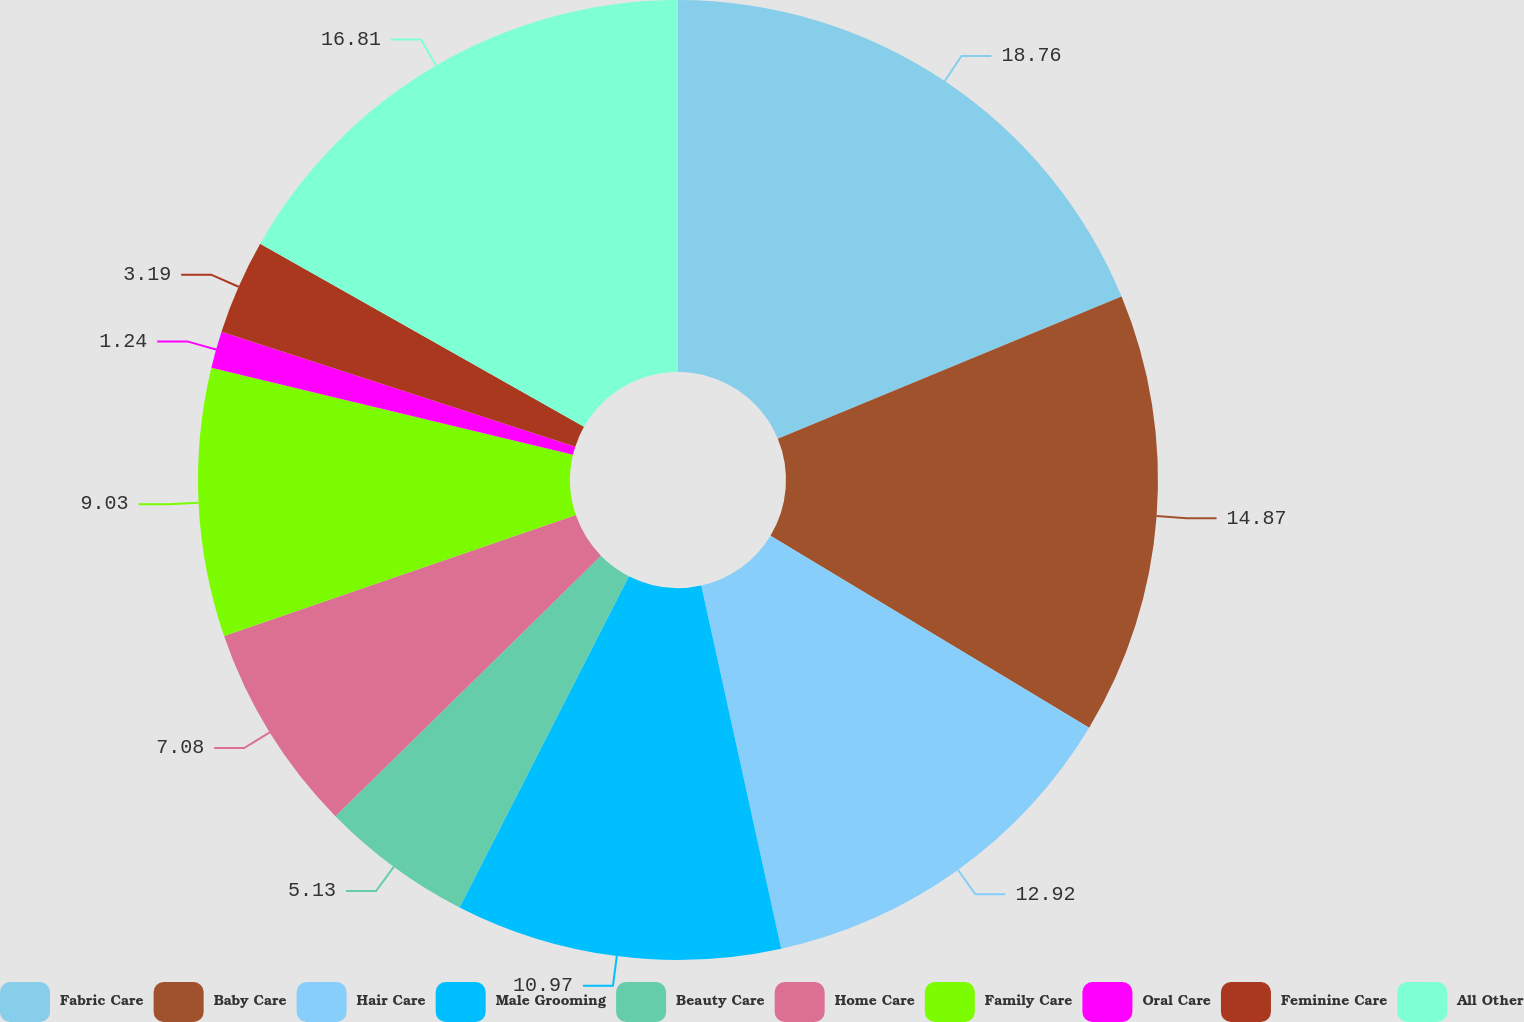Convert chart to OTSL. <chart><loc_0><loc_0><loc_500><loc_500><pie_chart><fcel>Fabric Care<fcel>Baby Care<fcel>Hair Care<fcel>Male Grooming<fcel>Beauty Care<fcel>Home Care<fcel>Family Care<fcel>Oral Care<fcel>Feminine Care<fcel>All Other<nl><fcel>18.76%<fcel>14.87%<fcel>12.92%<fcel>10.97%<fcel>5.13%<fcel>7.08%<fcel>9.03%<fcel>1.24%<fcel>3.19%<fcel>16.81%<nl></chart> 